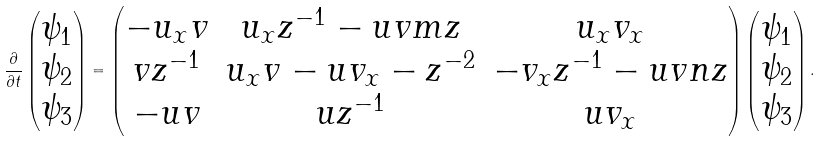Convert formula to latex. <formula><loc_0><loc_0><loc_500><loc_500>\frac { \partial } { \partial t } \begin{pmatrix} \psi _ { 1 } \\ \psi _ { 2 } \\ \psi _ { 3 } \end{pmatrix} = \begin{pmatrix} - u _ { x } v & u _ { x } z ^ { - 1 } - u v m z & u _ { x } v _ { x } \\ v z ^ { - 1 } & u _ { x } v - u v _ { x } - z ^ { - 2 } & - v _ { x } z ^ { - 1 } - u v n z \\ - u v & u z ^ { - 1 } & u v _ { x } \end{pmatrix} \begin{pmatrix} \psi _ { 1 } \\ \psi _ { 2 } \\ \psi _ { 3 } \end{pmatrix} .</formula> 